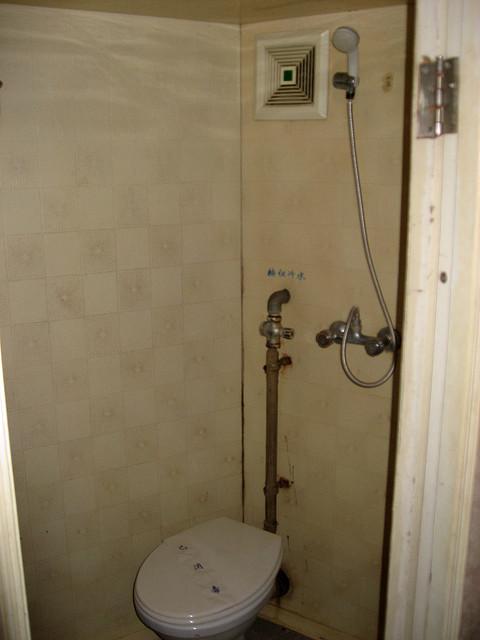Is there a shower in this bathroom?
Answer briefly. Yes. Is the toilet lid closed or open?
Short answer required. Closed. Is the toilet seat up?
Keep it brief. No. What are the walls made of?
Answer briefly. Tile. What color is the faucet head?
Give a very brief answer. White. What is the function of this item?
Be succinct. Shower. 